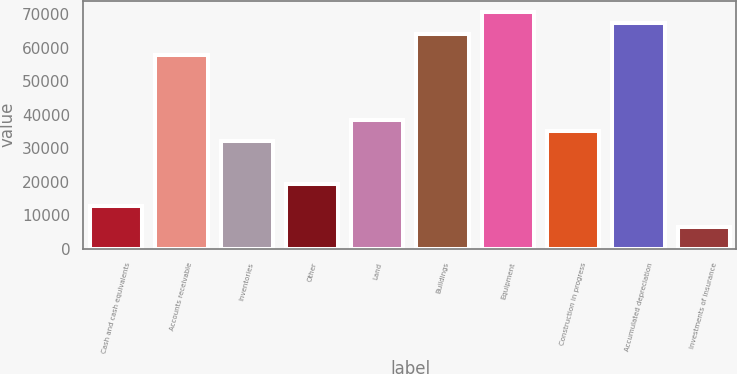Convert chart to OTSL. <chart><loc_0><loc_0><loc_500><loc_500><bar_chart><fcel>Cash and cash equivalents<fcel>Accounts receivable<fcel>Inventories<fcel>Other<fcel>Land<fcel>Buildings<fcel>Equipment<fcel>Construction in progress<fcel>Accumulated depreciation<fcel>Investments of insurance<nl><fcel>12815<fcel>57657<fcel>32033<fcel>19221<fcel>38439<fcel>64063<fcel>70469<fcel>35236<fcel>67266<fcel>6409<nl></chart> 